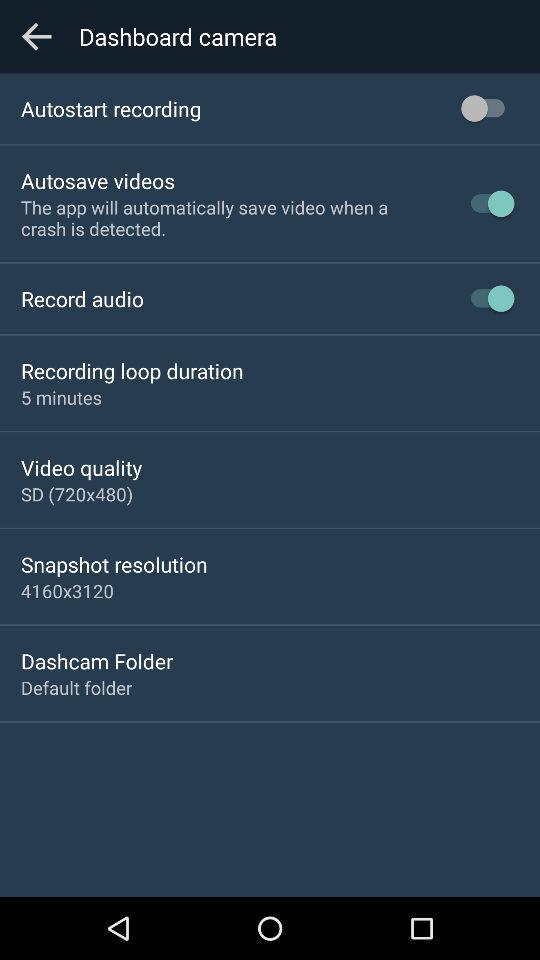What is the snapshot resolution? The snapshot resolution is 4160x3120. 